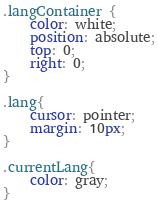Convert code to text. <code><loc_0><loc_0><loc_500><loc_500><_CSS_>.langContainer {
    color: white;
    position: absolute;
    top: 0;
    right: 0;
}

.lang{
    cursor: pointer;
    margin: 10px;
}

.currentLang{
    color: gray;
}</code> 